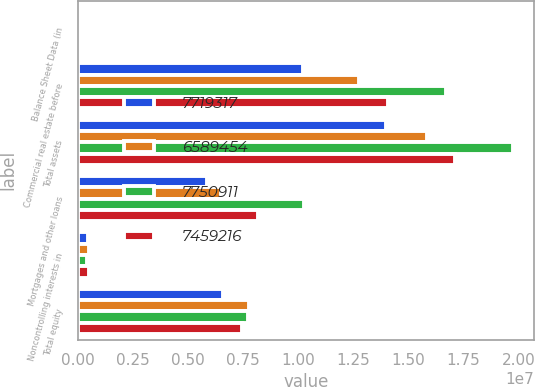<chart> <loc_0><loc_0><loc_500><loc_500><stacked_bar_chart><ecel><fcel>Balance Sheet Data (in<fcel>Commercial real estate before<fcel>Total assets<fcel>Mortgages and other loans<fcel>Noncontrolling interests in<fcel>Total equity<nl><fcel>7.71932e+06<fcel>2017<fcel>1.02061e+07<fcel>1.39829e+07<fcel>5.85513e+06<fcel>461954<fcel>6.58945e+06<nl><fcel>6.58945e+06<fcel>2016<fcel>1.27433e+07<fcel>1.58578e+07<fcel>6.48167e+06<fcel>473882<fcel>7.75091e+06<nl><fcel>7.75091e+06<fcel>2015<fcel>1.66816e+07<fcel>1.97276e+07<fcel>1.02755e+07<fcel>424206<fcel>7.71932e+06<nl><fcel>7.45922e+06<fcel>2014<fcel>1.40691e+07<fcel>1.70966e+07<fcel>8.17879e+06<fcel>496524<fcel>7.45922e+06<nl></chart> 